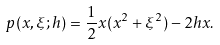Convert formula to latex. <formula><loc_0><loc_0><loc_500><loc_500>p ( x , \xi ; h ) = \frac { 1 } { 2 } x ( x ^ { 2 } + \xi ^ { 2 } ) - 2 h x .</formula> 